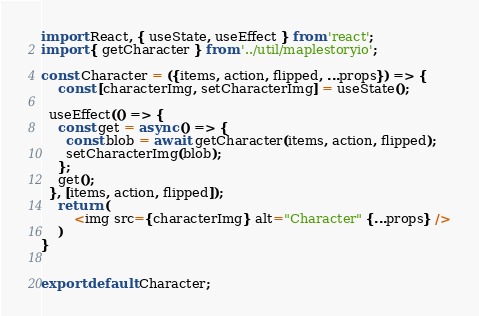<code> <loc_0><loc_0><loc_500><loc_500><_JavaScript_>import React, { useState, useEffect } from 'react';
import { getCharacter } from '../util/maplestoryio';

const Character = ({items, action, flipped, ...props}) => {
    const [characterImg, setCharacterImg] = useState();

  useEffect(() => {
    const get = async () => {
      const blob = await getCharacter(items, action, flipped);
      setCharacterImg(blob);
    };
    get();
  }, [items, action, flipped]);
    return (
        <img src={characterImg} alt="Character" {...props} />
    )
}


export default Character;
</code> 